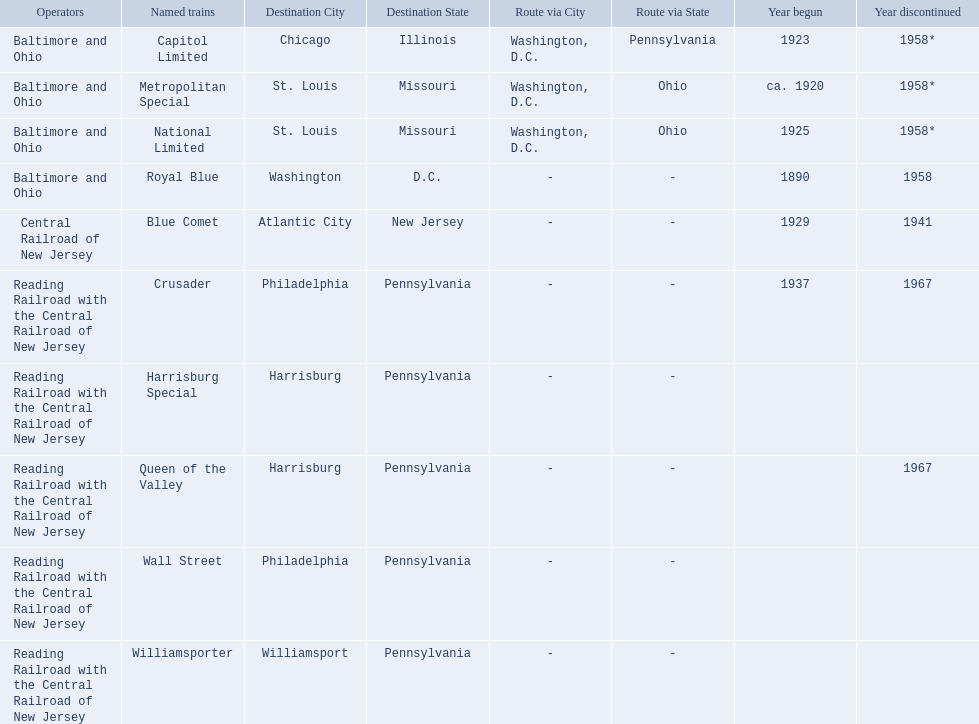What destinations are there? Chicago, Illinois via Washington, D.C. and Pittsburgh, Pennsylvania, St. Louis, Missouri via Washington, D.C. and Cincinnati, Ohio, St. Louis, Missouri via Washington, D.C. and Cincinnati, Ohio, Washington, D.C., Atlantic City, New Jersey, Philadelphia, Pennsylvania, Harrisburg, Pennsylvania, Harrisburg, Pennsylvania, Philadelphia, Pennsylvania, Williamsport, Pennsylvania. Which one is at the top of the list? Chicago, Illinois via Washington, D.C. and Pittsburgh, Pennsylvania. 